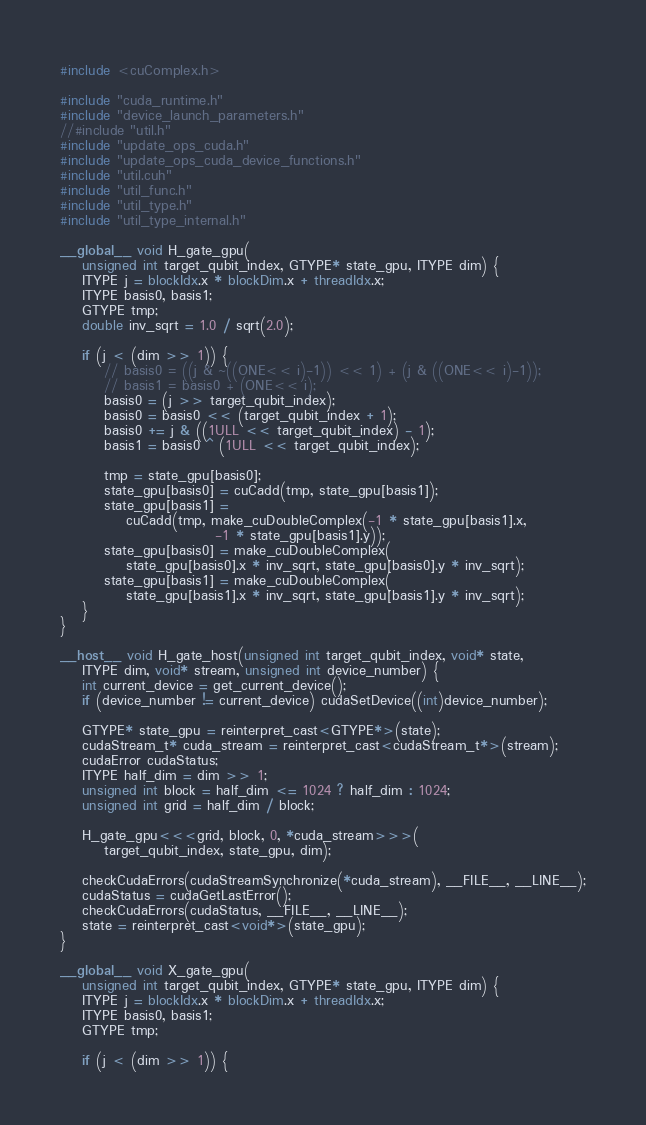<code> <loc_0><loc_0><loc_500><loc_500><_Cuda_>#include <cuComplex.h>

#include "cuda_runtime.h"
#include "device_launch_parameters.h"
//#include "util.h"
#include "update_ops_cuda.h"
#include "update_ops_cuda_device_functions.h"
#include "util.cuh"
#include "util_func.h"
#include "util_type.h"
#include "util_type_internal.h"

__global__ void H_gate_gpu(
    unsigned int target_qubit_index, GTYPE* state_gpu, ITYPE dim) {
    ITYPE j = blockIdx.x * blockDim.x + threadIdx.x;
    ITYPE basis0, basis1;
    GTYPE tmp;
    double inv_sqrt = 1.0 / sqrt(2.0);

    if (j < (dim >> 1)) {
        // basis0 = ((j & ~((ONE<< i)-1)) << 1) + (j & ((ONE<< i)-1));
        // basis1 = basis0 + (ONE<< i);
        basis0 = (j >> target_qubit_index);
        basis0 = basis0 << (target_qubit_index + 1);
        basis0 += j & ((1ULL << target_qubit_index) - 1);
        basis1 = basis0 ^ (1ULL << target_qubit_index);

        tmp = state_gpu[basis0];
        state_gpu[basis0] = cuCadd(tmp, state_gpu[basis1]);
        state_gpu[basis1] =
            cuCadd(tmp, make_cuDoubleComplex(-1 * state_gpu[basis1].x,
                            -1 * state_gpu[basis1].y));
        state_gpu[basis0] = make_cuDoubleComplex(
            state_gpu[basis0].x * inv_sqrt, state_gpu[basis0].y * inv_sqrt);
        state_gpu[basis1] = make_cuDoubleComplex(
            state_gpu[basis1].x * inv_sqrt, state_gpu[basis1].y * inv_sqrt);
    }
}

__host__ void H_gate_host(unsigned int target_qubit_index, void* state,
    ITYPE dim, void* stream, unsigned int device_number) {
    int current_device = get_current_device();
    if (device_number != current_device) cudaSetDevice((int)device_number);

    GTYPE* state_gpu = reinterpret_cast<GTYPE*>(state);
    cudaStream_t* cuda_stream = reinterpret_cast<cudaStream_t*>(stream);
    cudaError cudaStatus;
    ITYPE half_dim = dim >> 1;
    unsigned int block = half_dim <= 1024 ? half_dim : 1024;
    unsigned int grid = half_dim / block;

    H_gate_gpu<<<grid, block, 0, *cuda_stream>>>(
        target_qubit_index, state_gpu, dim);

    checkCudaErrors(cudaStreamSynchronize(*cuda_stream), __FILE__, __LINE__);
    cudaStatus = cudaGetLastError();
    checkCudaErrors(cudaStatus, __FILE__, __LINE__);
    state = reinterpret_cast<void*>(state_gpu);
}

__global__ void X_gate_gpu(
    unsigned int target_qubit_index, GTYPE* state_gpu, ITYPE dim) {
    ITYPE j = blockIdx.x * blockDim.x + threadIdx.x;
    ITYPE basis0, basis1;
    GTYPE tmp;

    if (j < (dim >> 1)) {</code> 